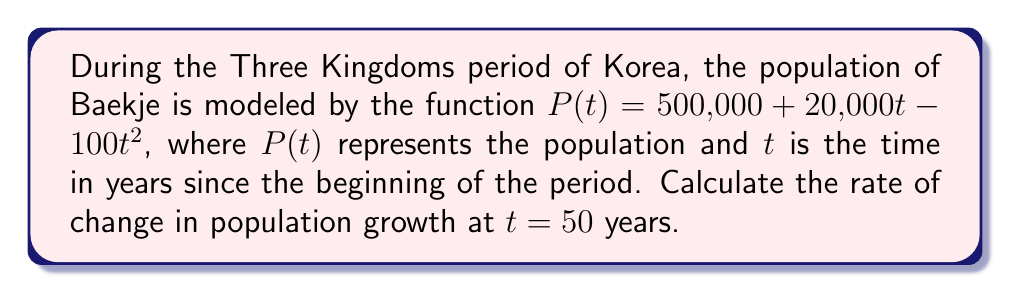Can you answer this question? To find the rate of change in population growth at $t = 50$ years, we need to calculate the derivative of the population function $P(t)$ and evaluate it at $t = 50$.

Step 1: Find the derivative of $P(t)$.
$$P(t) = 500,000 + 20,000t - 100t^2$$
$$P'(t) = 20,000 - 200t$$

Step 2: Evaluate $P'(t)$ at $t = 50$.
$$P'(50) = 20,000 - 200(50)$$
$$P'(50) = 20,000 - 10,000$$
$$P'(50) = 10,000$$

The rate of change in population growth at $t = 50$ years is 10,000 people per year.
Answer: $10,000$ people/year 